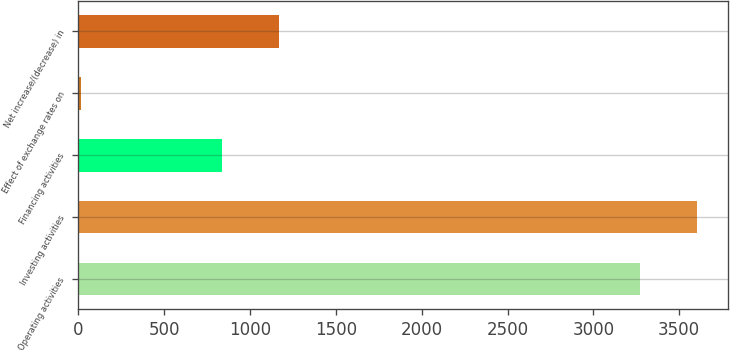Convert chart. <chart><loc_0><loc_0><loc_500><loc_500><bar_chart><fcel>Operating activities<fcel>Investing activities<fcel>Financing activities<fcel>Effect of exchange rates on<fcel>Net increase/(decrease) in<nl><fcel>3274<fcel>3603.2<fcel>838<fcel>15<fcel>1167.2<nl></chart> 